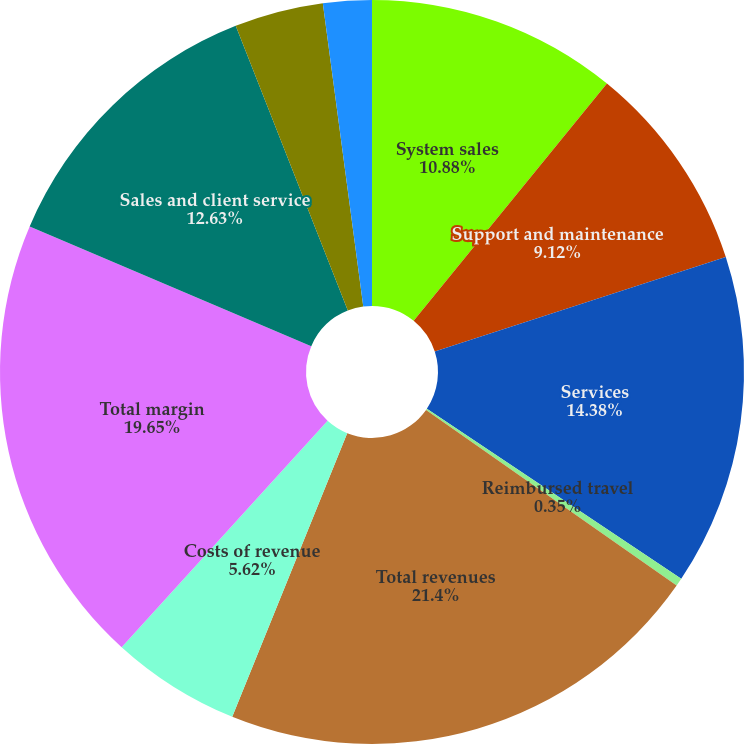Convert chart to OTSL. <chart><loc_0><loc_0><loc_500><loc_500><pie_chart><fcel>System sales<fcel>Support and maintenance<fcel>Services<fcel>Reimbursed travel<fcel>Total revenues<fcel>Costs of revenue<fcel>Total margin<fcel>Sales and client service<fcel>Software development<fcel>General and administrative<nl><fcel>10.88%<fcel>9.12%<fcel>14.38%<fcel>0.35%<fcel>21.4%<fcel>5.62%<fcel>19.65%<fcel>12.63%<fcel>3.86%<fcel>2.11%<nl></chart> 